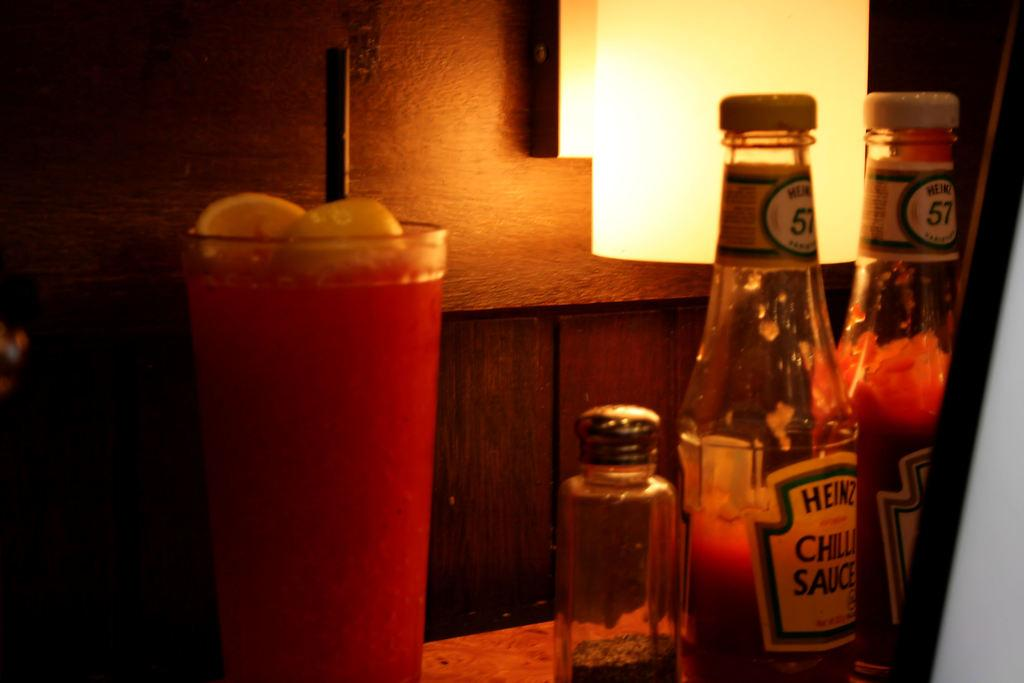<image>
Give a short and clear explanation of the subsequent image. a bottle that says Heinz on the front 